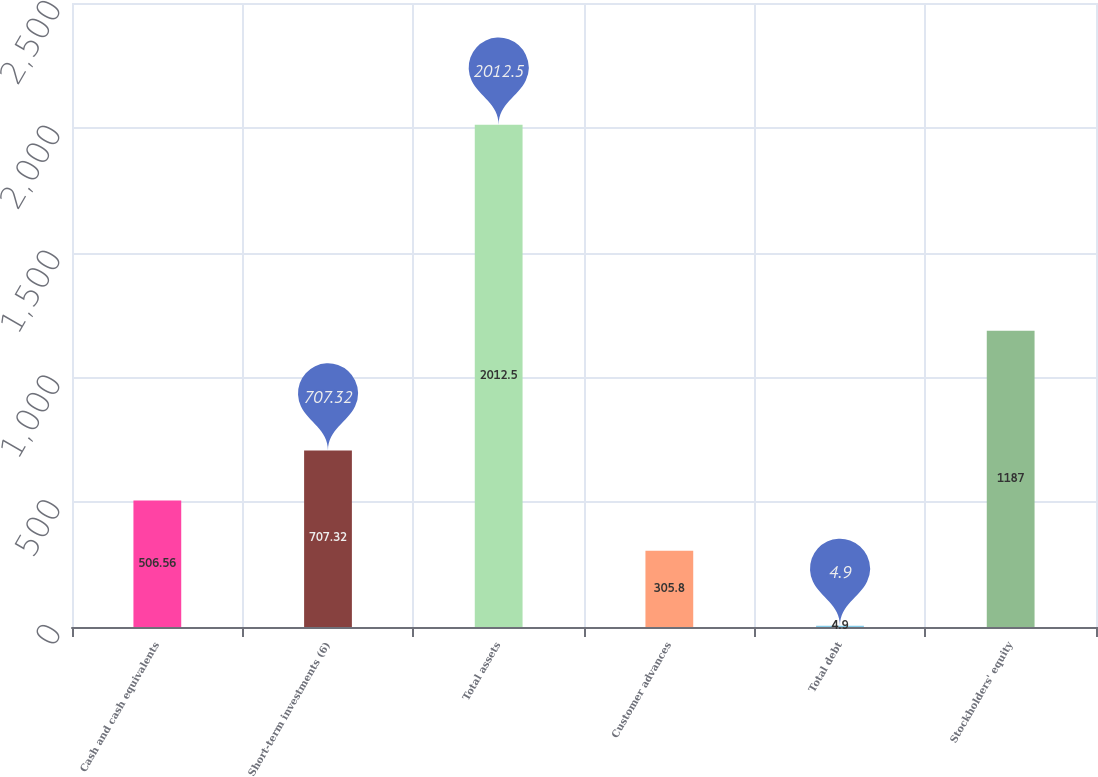Convert chart. <chart><loc_0><loc_0><loc_500><loc_500><bar_chart><fcel>Cash and cash equivalents<fcel>Short-term investments (6)<fcel>Total assets<fcel>Customer advances<fcel>Total debt<fcel>Stockholders' equity<nl><fcel>506.56<fcel>707.32<fcel>2012.5<fcel>305.8<fcel>4.9<fcel>1187<nl></chart> 